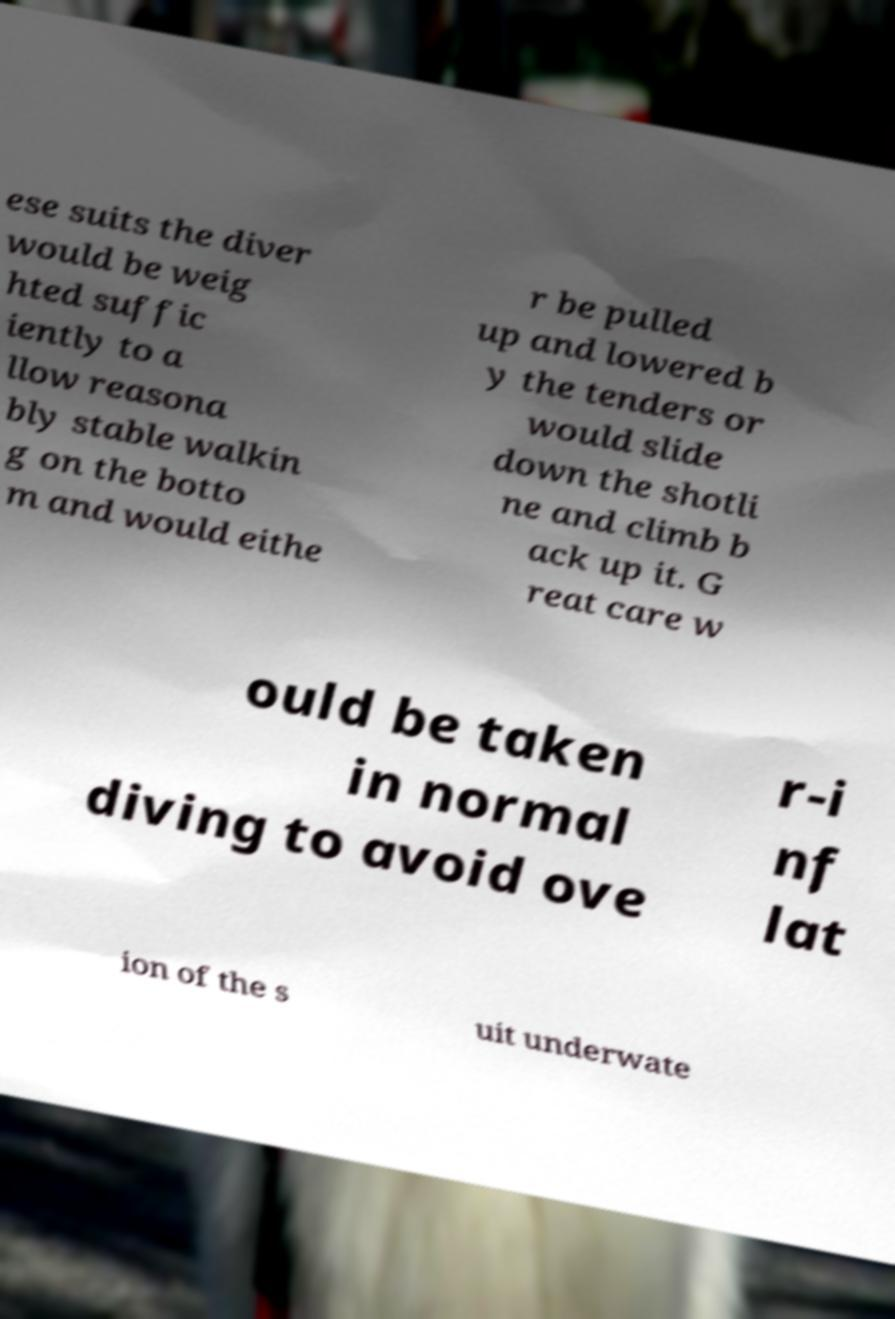Could you extract and type out the text from this image? ese suits the diver would be weig hted suffic iently to a llow reasona bly stable walkin g on the botto m and would eithe r be pulled up and lowered b y the tenders or would slide down the shotli ne and climb b ack up it. G reat care w ould be taken in normal diving to avoid ove r-i nf lat ion of the s uit underwate 